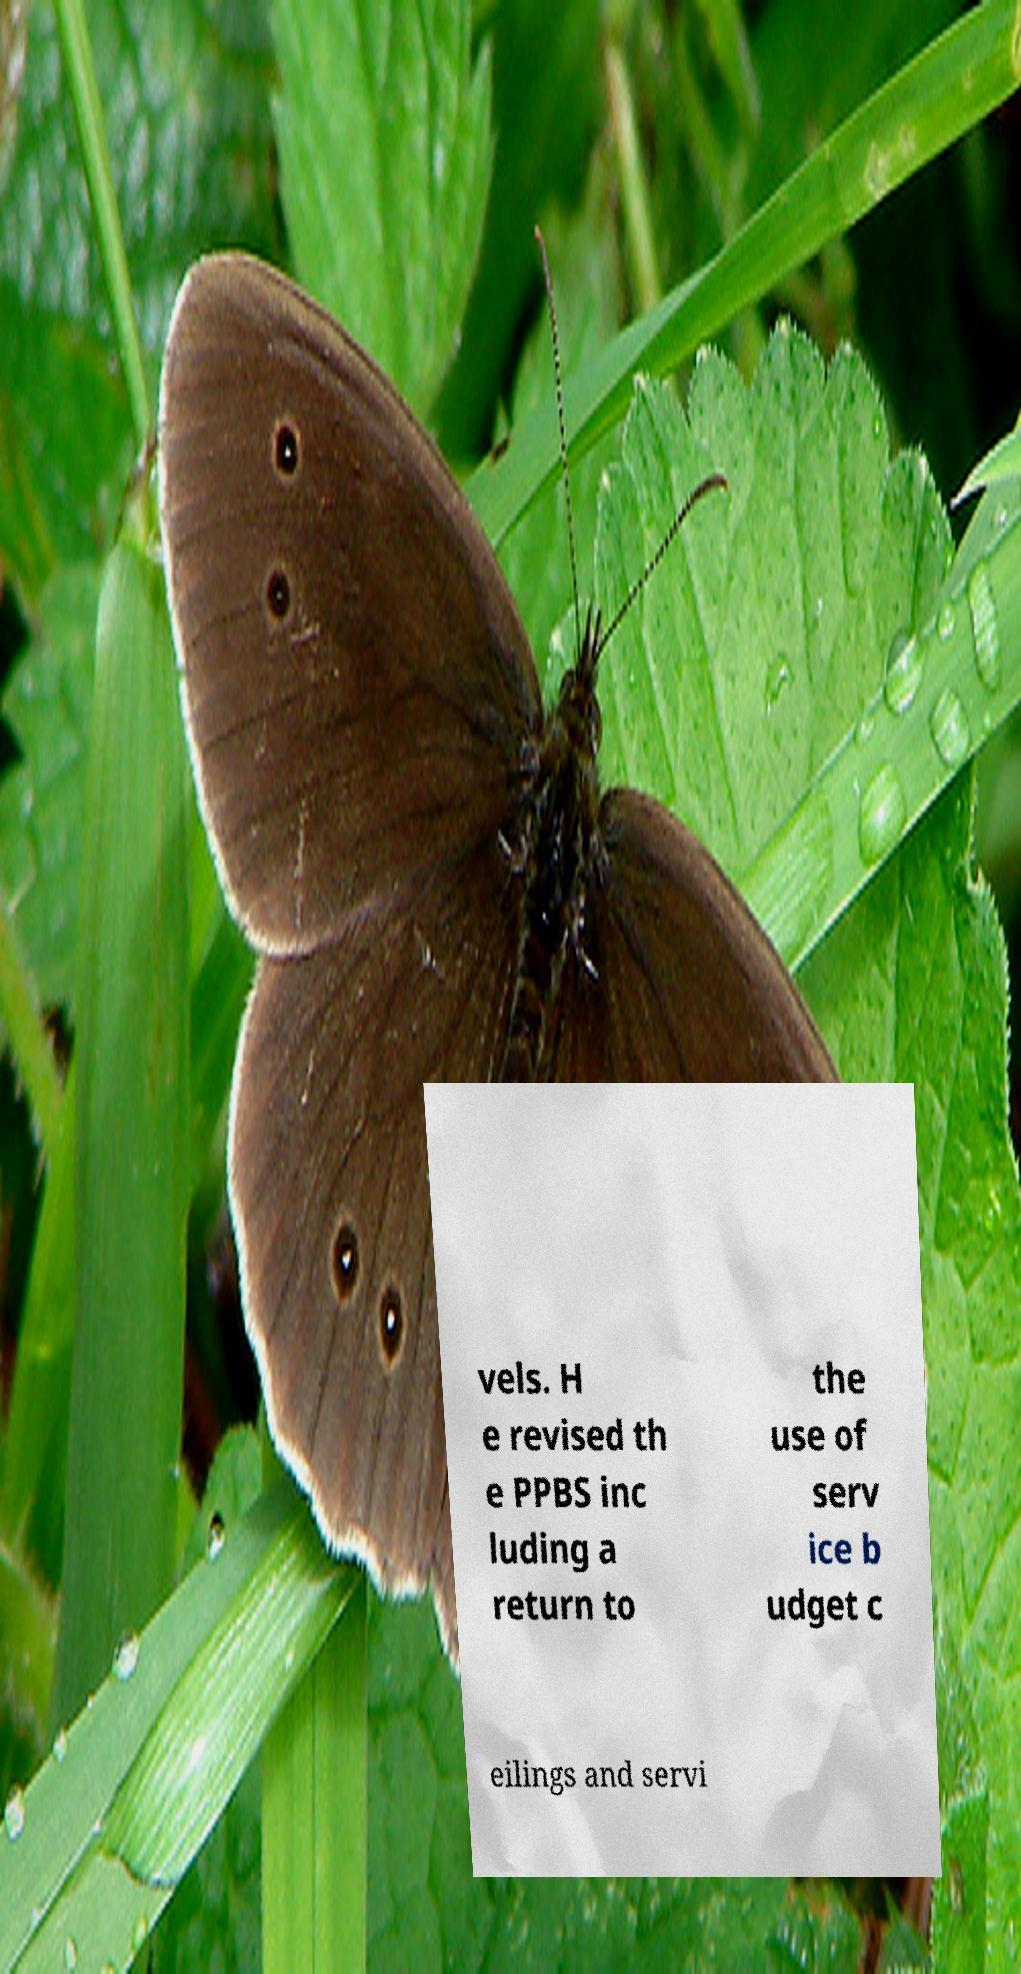Please identify and transcribe the text found in this image. vels. H e revised th e PPBS inc luding a return to the use of serv ice b udget c eilings and servi 